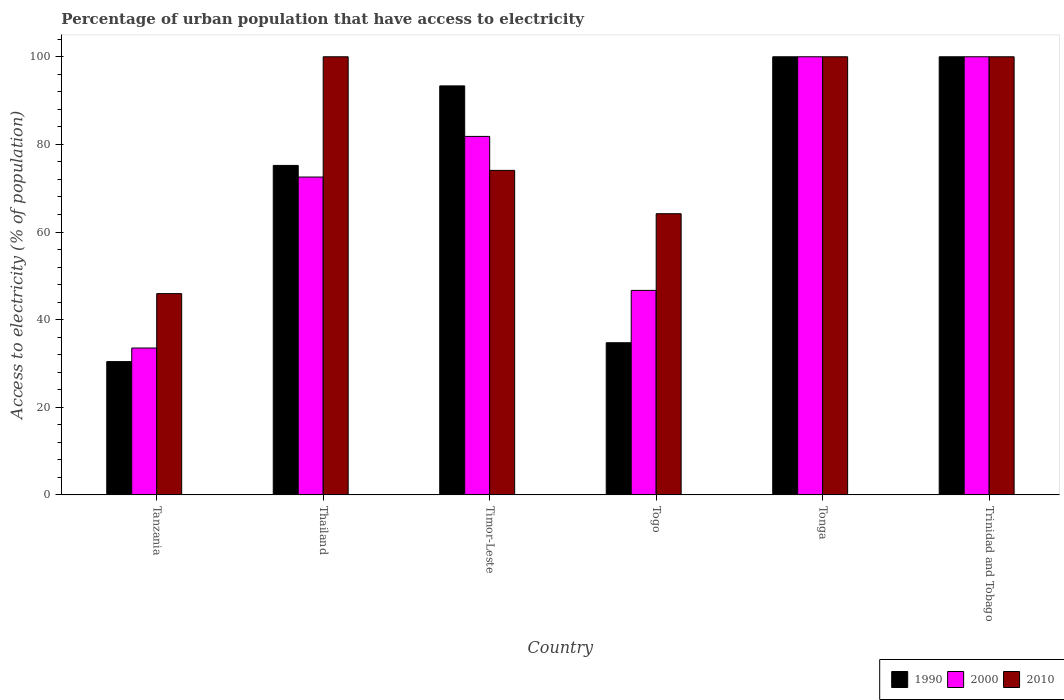How many groups of bars are there?
Make the answer very short. 6. Are the number of bars per tick equal to the number of legend labels?
Keep it short and to the point. Yes. How many bars are there on the 6th tick from the right?
Your answer should be very brief. 3. What is the label of the 1st group of bars from the left?
Provide a short and direct response. Tanzania. In how many cases, is the number of bars for a given country not equal to the number of legend labels?
Your answer should be very brief. 0. What is the percentage of urban population that have access to electricity in 1990 in Tanzania?
Provide a succinct answer. 30.43. Across all countries, what is the maximum percentage of urban population that have access to electricity in 2010?
Offer a very short reply. 100. Across all countries, what is the minimum percentage of urban population that have access to electricity in 2000?
Keep it short and to the point. 33.53. In which country was the percentage of urban population that have access to electricity in 2010 maximum?
Your answer should be compact. Thailand. In which country was the percentage of urban population that have access to electricity in 1990 minimum?
Keep it short and to the point. Tanzania. What is the total percentage of urban population that have access to electricity in 1990 in the graph?
Give a very brief answer. 433.71. What is the difference between the percentage of urban population that have access to electricity in 2010 in Tanzania and that in Thailand?
Make the answer very short. -54.06. What is the difference between the percentage of urban population that have access to electricity in 2000 in Thailand and the percentage of urban population that have access to electricity in 2010 in Tanzania?
Provide a short and direct response. 26.61. What is the average percentage of urban population that have access to electricity in 2000 per country?
Offer a terse response. 72.43. In how many countries, is the percentage of urban population that have access to electricity in 2000 greater than 96 %?
Give a very brief answer. 2. What is the ratio of the percentage of urban population that have access to electricity in 2010 in Tanzania to that in Trinidad and Tobago?
Make the answer very short. 0.46. What is the difference between the highest and the second highest percentage of urban population that have access to electricity in 2000?
Keep it short and to the point. -18.17. What is the difference between the highest and the lowest percentage of urban population that have access to electricity in 2000?
Provide a short and direct response. 66.47. In how many countries, is the percentage of urban population that have access to electricity in 2000 greater than the average percentage of urban population that have access to electricity in 2000 taken over all countries?
Your answer should be compact. 4. What does the 1st bar from the left in Trinidad and Tobago represents?
Your response must be concise. 1990. What does the 1st bar from the right in Trinidad and Tobago represents?
Offer a very short reply. 2010. Is it the case that in every country, the sum of the percentage of urban population that have access to electricity in 1990 and percentage of urban population that have access to electricity in 2000 is greater than the percentage of urban population that have access to electricity in 2010?
Give a very brief answer. Yes. How many bars are there?
Offer a terse response. 18. How many countries are there in the graph?
Your answer should be very brief. 6. What is the difference between two consecutive major ticks on the Y-axis?
Give a very brief answer. 20. Does the graph contain grids?
Your answer should be very brief. No. How many legend labels are there?
Offer a terse response. 3. What is the title of the graph?
Keep it short and to the point. Percentage of urban population that have access to electricity. What is the label or title of the Y-axis?
Give a very brief answer. Access to electricity (% of population). What is the Access to electricity (% of population) of 1990 in Tanzania?
Offer a terse response. 30.43. What is the Access to electricity (% of population) of 2000 in Tanzania?
Offer a terse response. 33.53. What is the Access to electricity (% of population) in 2010 in Tanzania?
Your response must be concise. 45.94. What is the Access to electricity (% of population) of 1990 in Thailand?
Provide a short and direct response. 75.2. What is the Access to electricity (% of population) in 2000 in Thailand?
Provide a succinct answer. 72.55. What is the Access to electricity (% of population) of 2010 in Thailand?
Provide a short and direct response. 100. What is the Access to electricity (% of population) of 1990 in Timor-Leste?
Ensure brevity in your answer.  93.35. What is the Access to electricity (% of population) of 2000 in Timor-Leste?
Your response must be concise. 81.83. What is the Access to electricity (% of population) in 2010 in Timor-Leste?
Keep it short and to the point. 74.07. What is the Access to electricity (% of population) in 1990 in Togo?
Make the answer very short. 34.73. What is the Access to electricity (% of population) in 2000 in Togo?
Your response must be concise. 46.68. What is the Access to electricity (% of population) of 2010 in Togo?
Your answer should be very brief. 64.18. What is the Access to electricity (% of population) of 1990 in Tonga?
Offer a terse response. 100. What is the Access to electricity (% of population) of 1990 in Trinidad and Tobago?
Your answer should be very brief. 100. What is the Access to electricity (% of population) in 2010 in Trinidad and Tobago?
Make the answer very short. 100. Across all countries, what is the minimum Access to electricity (% of population) in 1990?
Make the answer very short. 30.43. Across all countries, what is the minimum Access to electricity (% of population) in 2000?
Offer a terse response. 33.53. Across all countries, what is the minimum Access to electricity (% of population) of 2010?
Ensure brevity in your answer.  45.94. What is the total Access to electricity (% of population) in 1990 in the graph?
Your answer should be very brief. 433.71. What is the total Access to electricity (% of population) in 2000 in the graph?
Provide a short and direct response. 434.58. What is the total Access to electricity (% of population) in 2010 in the graph?
Provide a succinct answer. 484.19. What is the difference between the Access to electricity (% of population) of 1990 in Tanzania and that in Thailand?
Offer a very short reply. -44.78. What is the difference between the Access to electricity (% of population) in 2000 in Tanzania and that in Thailand?
Your answer should be very brief. -39.02. What is the difference between the Access to electricity (% of population) of 2010 in Tanzania and that in Thailand?
Your answer should be very brief. -54.06. What is the difference between the Access to electricity (% of population) of 1990 in Tanzania and that in Timor-Leste?
Ensure brevity in your answer.  -62.93. What is the difference between the Access to electricity (% of population) of 2000 in Tanzania and that in Timor-Leste?
Make the answer very short. -48.3. What is the difference between the Access to electricity (% of population) in 2010 in Tanzania and that in Timor-Leste?
Your response must be concise. -28.13. What is the difference between the Access to electricity (% of population) in 1990 in Tanzania and that in Togo?
Your response must be concise. -4.3. What is the difference between the Access to electricity (% of population) of 2000 in Tanzania and that in Togo?
Provide a succinct answer. -13.15. What is the difference between the Access to electricity (% of population) in 2010 in Tanzania and that in Togo?
Provide a short and direct response. -18.24. What is the difference between the Access to electricity (% of population) in 1990 in Tanzania and that in Tonga?
Make the answer very short. -69.57. What is the difference between the Access to electricity (% of population) in 2000 in Tanzania and that in Tonga?
Ensure brevity in your answer.  -66.47. What is the difference between the Access to electricity (% of population) of 2010 in Tanzania and that in Tonga?
Provide a succinct answer. -54.06. What is the difference between the Access to electricity (% of population) in 1990 in Tanzania and that in Trinidad and Tobago?
Offer a terse response. -69.57. What is the difference between the Access to electricity (% of population) in 2000 in Tanzania and that in Trinidad and Tobago?
Give a very brief answer. -66.47. What is the difference between the Access to electricity (% of population) in 2010 in Tanzania and that in Trinidad and Tobago?
Keep it short and to the point. -54.06. What is the difference between the Access to electricity (% of population) of 1990 in Thailand and that in Timor-Leste?
Make the answer very short. -18.15. What is the difference between the Access to electricity (% of population) in 2000 in Thailand and that in Timor-Leste?
Your answer should be compact. -9.27. What is the difference between the Access to electricity (% of population) in 2010 in Thailand and that in Timor-Leste?
Your response must be concise. 25.93. What is the difference between the Access to electricity (% of population) of 1990 in Thailand and that in Togo?
Provide a succinct answer. 40.47. What is the difference between the Access to electricity (% of population) of 2000 in Thailand and that in Togo?
Give a very brief answer. 25.87. What is the difference between the Access to electricity (% of population) of 2010 in Thailand and that in Togo?
Give a very brief answer. 35.82. What is the difference between the Access to electricity (% of population) in 1990 in Thailand and that in Tonga?
Keep it short and to the point. -24.8. What is the difference between the Access to electricity (% of population) of 2000 in Thailand and that in Tonga?
Provide a succinct answer. -27.45. What is the difference between the Access to electricity (% of population) of 2010 in Thailand and that in Tonga?
Offer a terse response. 0. What is the difference between the Access to electricity (% of population) in 1990 in Thailand and that in Trinidad and Tobago?
Make the answer very short. -24.8. What is the difference between the Access to electricity (% of population) in 2000 in Thailand and that in Trinidad and Tobago?
Offer a terse response. -27.45. What is the difference between the Access to electricity (% of population) in 1990 in Timor-Leste and that in Togo?
Your response must be concise. 58.63. What is the difference between the Access to electricity (% of population) of 2000 in Timor-Leste and that in Togo?
Give a very brief answer. 35.15. What is the difference between the Access to electricity (% of population) of 2010 in Timor-Leste and that in Togo?
Offer a very short reply. 9.89. What is the difference between the Access to electricity (% of population) in 1990 in Timor-Leste and that in Tonga?
Ensure brevity in your answer.  -6.65. What is the difference between the Access to electricity (% of population) of 2000 in Timor-Leste and that in Tonga?
Offer a terse response. -18.17. What is the difference between the Access to electricity (% of population) of 2010 in Timor-Leste and that in Tonga?
Ensure brevity in your answer.  -25.93. What is the difference between the Access to electricity (% of population) in 1990 in Timor-Leste and that in Trinidad and Tobago?
Provide a succinct answer. -6.65. What is the difference between the Access to electricity (% of population) in 2000 in Timor-Leste and that in Trinidad and Tobago?
Your answer should be very brief. -18.17. What is the difference between the Access to electricity (% of population) in 2010 in Timor-Leste and that in Trinidad and Tobago?
Your response must be concise. -25.93. What is the difference between the Access to electricity (% of population) in 1990 in Togo and that in Tonga?
Offer a terse response. -65.27. What is the difference between the Access to electricity (% of population) in 2000 in Togo and that in Tonga?
Provide a short and direct response. -53.32. What is the difference between the Access to electricity (% of population) in 2010 in Togo and that in Tonga?
Provide a short and direct response. -35.82. What is the difference between the Access to electricity (% of population) of 1990 in Togo and that in Trinidad and Tobago?
Offer a terse response. -65.27. What is the difference between the Access to electricity (% of population) in 2000 in Togo and that in Trinidad and Tobago?
Make the answer very short. -53.32. What is the difference between the Access to electricity (% of population) in 2010 in Togo and that in Trinidad and Tobago?
Your answer should be compact. -35.82. What is the difference between the Access to electricity (% of population) in 2000 in Tonga and that in Trinidad and Tobago?
Make the answer very short. 0. What is the difference between the Access to electricity (% of population) of 1990 in Tanzania and the Access to electricity (% of population) of 2000 in Thailand?
Offer a terse response. -42.13. What is the difference between the Access to electricity (% of population) of 1990 in Tanzania and the Access to electricity (% of population) of 2010 in Thailand?
Offer a terse response. -69.57. What is the difference between the Access to electricity (% of population) of 2000 in Tanzania and the Access to electricity (% of population) of 2010 in Thailand?
Keep it short and to the point. -66.47. What is the difference between the Access to electricity (% of population) in 1990 in Tanzania and the Access to electricity (% of population) in 2000 in Timor-Leste?
Ensure brevity in your answer.  -51.4. What is the difference between the Access to electricity (% of population) in 1990 in Tanzania and the Access to electricity (% of population) in 2010 in Timor-Leste?
Your answer should be compact. -43.65. What is the difference between the Access to electricity (% of population) of 2000 in Tanzania and the Access to electricity (% of population) of 2010 in Timor-Leste?
Your answer should be compact. -40.55. What is the difference between the Access to electricity (% of population) in 1990 in Tanzania and the Access to electricity (% of population) in 2000 in Togo?
Your answer should be very brief. -16.25. What is the difference between the Access to electricity (% of population) in 1990 in Tanzania and the Access to electricity (% of population) in 2010 in Togo?
Ensure brevity in your answer.  -33.76. What is the difference between the Access to electricity (% of population) in 2000 in Tanzania and the Access to electricity (% of population) in 2010 in Togo?
Your answer should be compact. -30.66. What is the difference between the Access to electricity (% of population) of 1990 in Tanzania and the Access to electricity (% of population) of 2000 in Tonga?
Make the answer very short. -69.57. What is the difference between the Access to electricity (% of population) in 1990 in Tanzania and the Access to electricity (% of population) in 2010 in Tonga?
Provide a succinct answer. -69.57. What is the difference between the Access to electricity (% of population) of 2000 in Tanzania and the Access to electricity (% of population) of 2010 in Tonga?
Provide a short and direct response. -66.47. What is the difference between the Access to electricity (% of population) in 1990 in Tanzania and the Access to electricity (% of population) in 2000 in Trinidad and Tobago?
Keep it short and to the point. -69.57. What is the difference between the Access to electricity (% of population) of 1990 in Tanzania and the Access to electricity (% of population) of 2010 in Trinidad and Tobago?
Ensure brevity in your answer.  -69.57. What is the difference between the Access to electricity (% of population) in 2000 in Tanzania and the Access to electricity (% of population) in 2010 in Trinidad and Tobago?
Provide a short and direct response. -66.47. What is the difference between the Access to electricity (% of population) in 1990 in Thailand and the Access to electricity (% of population) in 2000 in Timor-Leste?
Your response must be concise. -6.62. What is the difference between the Access to electricity (% of population) in 1990 in Thailand and the Access to electricity (% of population) in 2010 in Timor-Leste?
Provide a succinct answer. 1.13. What is the difference between the Access to electricity (% of population) of 2000 in Thailand and the Access to electricity (% of population) of 2010 in Timor-Leste?
Your response must be concise. -1.52. What is the difference between the Access to electricity (% of population) of 1990 in Thailand and the Access to electricity (% of population) of 2000 in Togo?
Your response must be concise. 28.53. What is the difference between the Access to electricity (% of population) of 1990 in Thailand and the Access to electricity (% of population) of 2010 in Togo?
Provide a short and direct response. 11.02. What is the difference between the Access to electricity (% of population) in 2000 in Thailand and the Access to electricity (% of population) in 2010 in Togo?
Keep it short and to the point. 8.37. What is the difference between the Access to electricity (% of population) of 1990 in Thailand and the Access to electricity (% of population) of 2000 in Tonga?
Make the answer very short. -24.8. What is the difference between the Access to electricity (% of population) in 1990 in Thailand and the Access to electricity (% of population) in 2010 in Tonga?
Give a very brief answer. -24.8. What is the difference between the Access to electricity (% of population) of 2000 in Thailand and the Access to electricity (% of population) of 2010 in Tonga?
Your response must be concise. -27.45. What is the difference between the Access to electricity (% of population) in 1990 in Thailand and the Access to electricity (% of population) in 2000 in Trinidad and Tobago?
Your response must be concise. -24.8. What is the difference between the Access to electricity (% of population) in 1990 in Thailand and the Access to electricity (% of population) in 2010 in Trinidad and Tobago?
Offer a very short reply. -24.8. What is the difference between the Access to electricity (% of population) of 2000 in Thailand and the Access to electricity (% of population) of 2010 in Trinidad and Tobago?
Your response must be concise. -27.45. What is the difference between the Access to electricity (% of population) in 1990 in Timor-Leste and the Access to electricity (% of population) in 2000 in Togo?
Give a very brief answer. 46.68. What is the difference between the Access to electricity (% of population) of 1990 in Timor-Leste and the Access to electricity (% of population) of 2010 in Togo?
Provide a short and direct response. 29.17. What is the difference between the Access to electricity (% of population) in 2000 in Timor-Leste and the Access to electricity (% of population) in 2010 in Togo?
Make the answer very short. 17.64. What is the difference between the Access to electricity (% of population) in 1990 in Timor-Leste and the Access to electricity (% of population) in 2000 in Tonga?
Your answer should be compact. -6.65. What is the difference between the Access to electricity (% of population) in 1990 in Timor-Leste and the Access to electricity (% of population) in 2010 in Tonga?
Your response must be concise. -6.65. What is the difference between the Access to electricity (% of population) of 2000 in Timor-Leste and the Access to electricity (% of population) of 2010 in Tonga?
Provide a short and direct response. -18.17. What is the difference between the Access to electricity (% of population) in 1990 in Timor-Leste and the Access to electricity (% of population) in 2000 in Trinidad and Tobago?
Offer a terse response. -6.65. What is the difference between the Access to electricity (% of population) of 1990 in Timor-Leste and the Access to electricity (% of population) of 2010 in Trinidad and Tobago?
Give a very brief answer. -6.65. What is the difference between the Access to electricity (% of population) of 2000 in Timor-Leste and the Access to electricity (% of population) of 2010 in Trinidad and Tobago?
Your answer should be very brief. -18.17. What is the difference between the Access to electricity (% of population) in 1990 in Togo and the Access to electricity (% of population) in 2000 in Tonga?
Make the answer very short. -65.27. What is the difference between the Access to electricity (% of population) of 1990 in Togo and the Access to electricity (% of population) of 2010 in Tonga?
Your answer should be very brief. -65.27. What is the difference between the Access to electricity (% of population) of 2000 in Togo and the Access to electricity (% of population) of 2010 in Tonga?
Your response must be concise. -53.32. What is the difference between the Access to electricity (% of population) in 1990 in Togo and the Access to electricity (% of population) in 2000 in Trinidad and Tobago?
Offer a terse response. -65.27. What is the difference between the Access to electricity (% of population) of 1990 in Togo and the Access to electricity (% of population) of 2010 in Trinidad and Tobago?
Your response must be concise. -65.27. What is the difference between the Access to electricity (% of population) in 2000 in Togo and the Access to electricity (% of population) in 2010 in Trinidad and Tobago?
Your answer should be very brief. -53.32. What is the difference between the Access to electricity (% of population) of 1990 in Tonga and the Access to electricity (% of population) of 2010 in Trinidad and Tobago?
Ensure brevity in your answer.  0. What is the average Access to electricity (% of population) of 1990 per country?
Your answer should be very brief. 72.29. What is the average Access to electricity (% of population) in 2000 per country?
Ensure brevity in your answer.  72.43. What is the average Access to electricity (% of population) of 2010 per country?
Offer a terse response. 80.7. What is the difference between the Access to electricity (% of population) of 1990 and Access to electricity (% of population) of 2000 in Tanzania?
Keep it short and to the point. -3.1. What is the difference between the Access to electricity (% of population) in 1990 and Access to electricity (% of population) in 2010 in Tanzania?
Make the answer very short. -15.51. What is the difference between the Access to electricity (% of population) in 2000 and Access to electricity (% of population) in 2010 in Tanzania?
Ensure brevity in your answer.  -12.41. What is the difference between the Access to electricity (% of population) of 1990 and Access to electricity (% of population) of 2000 in Thailand?
Make the answer very short. 2.65. What is the difference between the Access to electricity (% of population) of 1990 and Access to electricity (% of population) of 2010 in Thailand?
Your response must be concise. -24.8. What is the difference between the Access to electricity (% of population) of 2000 and Access to electricity (% of population) of 2010 in Thailand?
Your answer should be very brief. -27.45. What is the difference between the Access to electricity (% of population) of 1990 and Access to electricity (% of population) of 2000 in Timor-Leste?
Offer a very short reply. 11.53. What is the difference between the Access to electricity (% of population) of 1990 and Access to electricity (% of population) of 2010 in Timor-Leste?
Give a very brief answer. 19.28. What is the difference between the Access to electricity (% of population) in 2000 and Access to electricity (% of population) in 2010 in Timor-Leste?
Keep it short and to the point. 7.75. What is the difference between the Access to electricity (% of population) in 1990 and Access to electricity (% of population) in 2000 in Togo?
Your answer should be very brief. -11.95. What is the difference between the Access to electricity (% of population) in 1990 and Access to electricity (% of population) in 2010 in Togo?
Your response must be concise. -29.45. What is the difference between the Access to electricity (% of population) in 2000 and Access to electricity (% of population) in 2010 in Togo?
Ensure brevity in your answer.  -17.51. What is the difference between the Access to electricity (% of population) of 1990 and Access to electricity (% of population) of 2010 in Tonga?
Your answer should be very brief. 0. What is the difference between the Access to electricity (% of population) in 2000 and Access to electricity (% of population) in 2010 in Tonga?
Ensure brevity in your answer.  0. What is the difference between the Access to electricity (% of population) of 1990 and Access to electricity (% of population) of 2000 in Trinidad and Tobago?
Offer a terse response. 0. What is the ratio of the Access to electricity (% of population) in 1990 in Tanzania to that in Thailand?
Your response must be concise. 0.4. What is the ratio of the Access to electricity (% of population) of 2000 in Tanzania to that in Thailand?
Your response must be concise. 0.46. What is the ratio of the Access to electricity (% of population) of 2010 in Tanzania to that in Thailand?
Your answer should be very brief. 0.46. What is the ratio of the Access to electricity (% of population) of 1990 in Tanzania to that in Timor-Leste?
Provide a succinct answer. 0.33. What is the ratio of the Access to electricity (% of population) in 2000 in Tanzania to that in Timor-Leste?
Your answer should be compact. 0.41. What is the ratio of the Access to electricity (% of population) of 2010 in Tanzania to that in Timor-Leste?
Your answer should be compact. 0.62. What is the ratio of the Access to electricity (% of population) of 1990 in Tanzania to that in Togo?
Offer a terse response. 0.88. What is the ratio of the Access to electricity (% of population) of 2000 in Tanzania to that in Togo?
Offer a very short reply. 0.72. What is the ratio of the Access to electricity (% of population) of 2010 in Tanzania to that in Togo?
Ensure brevity in your answer.  0.72. What is the ratio of the Access to electricity (% of population) in 1990 in Tanzania to that in Tonga?
Make the answer very short. 0.3. What is the ratio of the Access to electricity (% of population) of 2000 in Tanzania to that in Tonga?
Keep it short and to the point. 0.34. What is the ratio of the Access to electricity (% of population) of 2010 in Tanzania to that in Tonga?
Your answer should be very brief. 0.46. What is the ratio of the Access to electricity (% of population) of 1990 in Tanzania to that in Trinidad and Tobago?
Give a very brief answer. 0.3. What is the ratio of the Access to electricity (% of population) of 2000 in Tanzania to that in Trinidad and Tobago?
Offer a terse response. 0.34. What is the ratio of the Access to electricity (% of population) of 2010 in Tanzania to that in Trinidad and Tobago?
Ensure brevity in your answer.  0.46. What is the ratio of the Access to electricity (% of population) of 1990 in Thailand to that in Timor-Leste?
Provide a short and direct response. 0.81. What is the ratio of the Access to electricity (% of population) of 2000 in Thailand to that in Timor-Leste?
Offer a very short reply. 0.89. What is the ratio of the Access to electricity (% of population) in 2010 in Thailand to that in Timor-Leste?
Provide a short and direct response. 1.35. What is the ratio of the Access to electricity (% of population) in 1990 in Thailand to that in Togo?
Make the answer very short. 2.17. What is the ratio of the Access to electricity (% of population) in 2000 in Thailand to that in Togo?
Provide a short and direct response. 1.55. What is the ratio of the Access to electricity (% of population) in 2010 in Thailand to that in Togo?
Provide a succinct answer. 1.56. What is the ratio of the Access to electricity (% of population) in 1990 in Thailand to that in Tonga?
Provide a succinct answer. 0.75. What is the ratio of the Access to electricity (% of population) of 2000 in Thailand to that in Tonga?
Your response must be concise. 0.73. What is the ratio of the Access to electricity (% of population) of 2010 in Thailand to that in Tonga?
Your response must be concise. 1. What is the ratio of the Access to electricity (% of population) in 1990 in Thailand to that in Trinidad and Tobago?
Give a very brief answer. 0.75. What is the ratio of the Access to electricity (% of population) of 2000 in Thailand to that in Trinidad and Tobago?
Ensure brevity in your answer.  0.73. What is the ratio of the Access to electricity (% of population) of 2010 in Thailand to that in Trinidad and Tobago?
Your answer should be very brief. 1. What is the ratio of the Access to electricity (% of population) in 1990 in Timor-Leste to that in Togo?
Provide a short and direct response. 2.69. What is the ratio of the Access to electricity (% of population) of 2000 in Timor-Leste to that in Togo?
Your answer should be very brief. 1.75. What is the ratio of the Access to electricity (% of population) of 2010 in Timor-Leste to that in Togo?
Ensure brevity in your answer.  1.15. What is the ratio of the Access to electricity (% of population) in 1990 in Timor-Leste to that in Tonga?
Your answer should be very brief. 0.93. What is the ratio of the Access to electricity (% of population) of 2000 in Timor-Leste to that in Tonga?
Give a very brief answer. 0.82. What is the ratio of the Access to electricity (% of population) of 2010 in Timor-Leste to that in Tonga?
Ensure brevity in your answer.  0.74. What is the ratio of the Access to electricity (% of population) in 1990 in Timor-Leste to that in Trinidad and Tobago?
Make the answer very short. 0.93. What is the ratio of the Access to electricity (% of population) of 2000 in Timor-Leste to that in Trinidad and Tobago?
Provide a succinct answer. 0.82. What is the ratio of the Access to electricity (% of population) in 2010 in Timor-Leste to that in Trinidad and Tobago?
Your response must be concise. 0.74. What is the ratio of the Access to electricity (% of population) of 1990 in Togo to that in Tonga?
Your answer should be compact. 0.35. What is the ratio of the Access to electricity (% of population) in 2000 in Togo to that in Tonga?
Make the answer very short. 0.47. What is the ratio of the Access to electricity (% of population) in 2010 in Togo to that in Tonga?
Offer a very short reply. 0.64. What is the ratio of the Access to electricity (% of population) of 1990 in Togo to that in Trinidad and Tobago?
Offer a terse response. 0.35. What is the ratio of the Access to electricity (% of population) of 2000 in Togo to that in Trinidad and Tobago?
Your response must be concise. 0.47. What is the ratio of the Access to electricity (% of population) in 2010 in Togo to that in Trinidad and Tobago?
Your answer should be compact. 0.64. What is the ratio of the Access to electricity (% of population) in 2000 in Tonga to that in Trinidad and Tobago?
Your response must be concise. 1. What is the difference between the highest and the lowest Access to electricity (% of population) in 1990?
Give a very brief answer. 69.57. What is the difference between the highest and the lowest Access to electricity (% of population) of 2000?
Your answer should be compact. 66.47. What is the difference between the highest and the lowest Access to electricity (% of population) in 2010?
Keep it short and to the point. 54.06. 